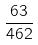<formula> <loc_0><loc_0><loc_500><loc_500>\frac { 6 3 } { 4 6 2 }</formula> 